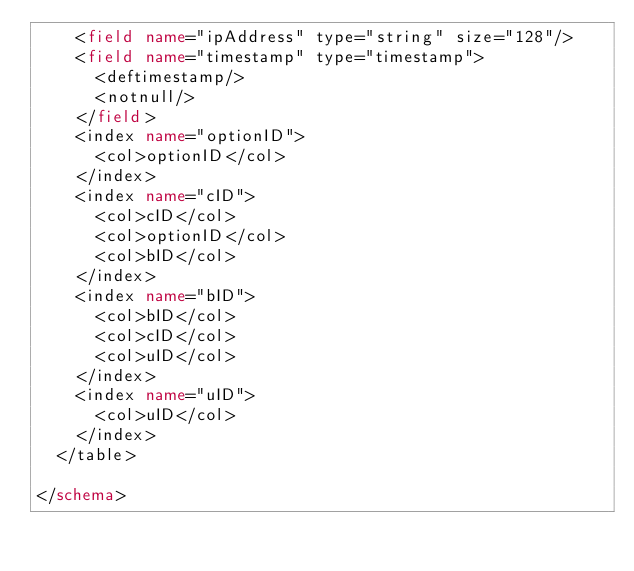Convert code to text. <code><loc_0><loc_0><loc_500><loc_500><_XML_>    <field name="ipAddress" type="string" size="128"/>
    <field name="timestamp" type="timestamp">
      <deftimestamp/>
      <notnull/>
    </field>
    <index name="optionID">
      <col>optionID</col>
    </index>
    <index name="cID">
      <col>cID</col>
      <col>optionID</col>
      <col>bID</col>
    </index>
    <index name="bID">
      <col>bID</col>
      <col>cID</col>
      <col>uID</col>
    </index>
    <index name="uID">
      <col>uID</col>
    </index>
  </table>

</schema>
</code> 